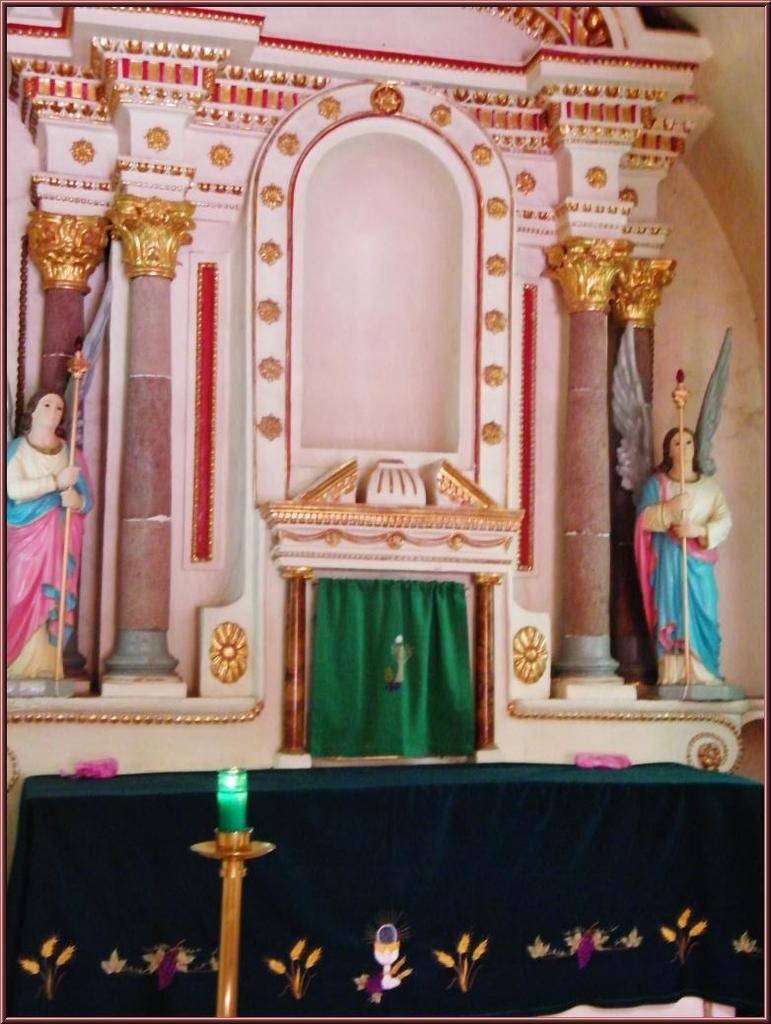Could you give a brief overview of what you see in this image? In this image there is a wall. There are sculptures on the wall. In front of the wall there is a table. There is a cloth spread on the table. At the bottom there is a candle on the candle holder. 